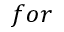<formula> <loc_0><loc_0><loc_500><loc_500>f o r</formula> 